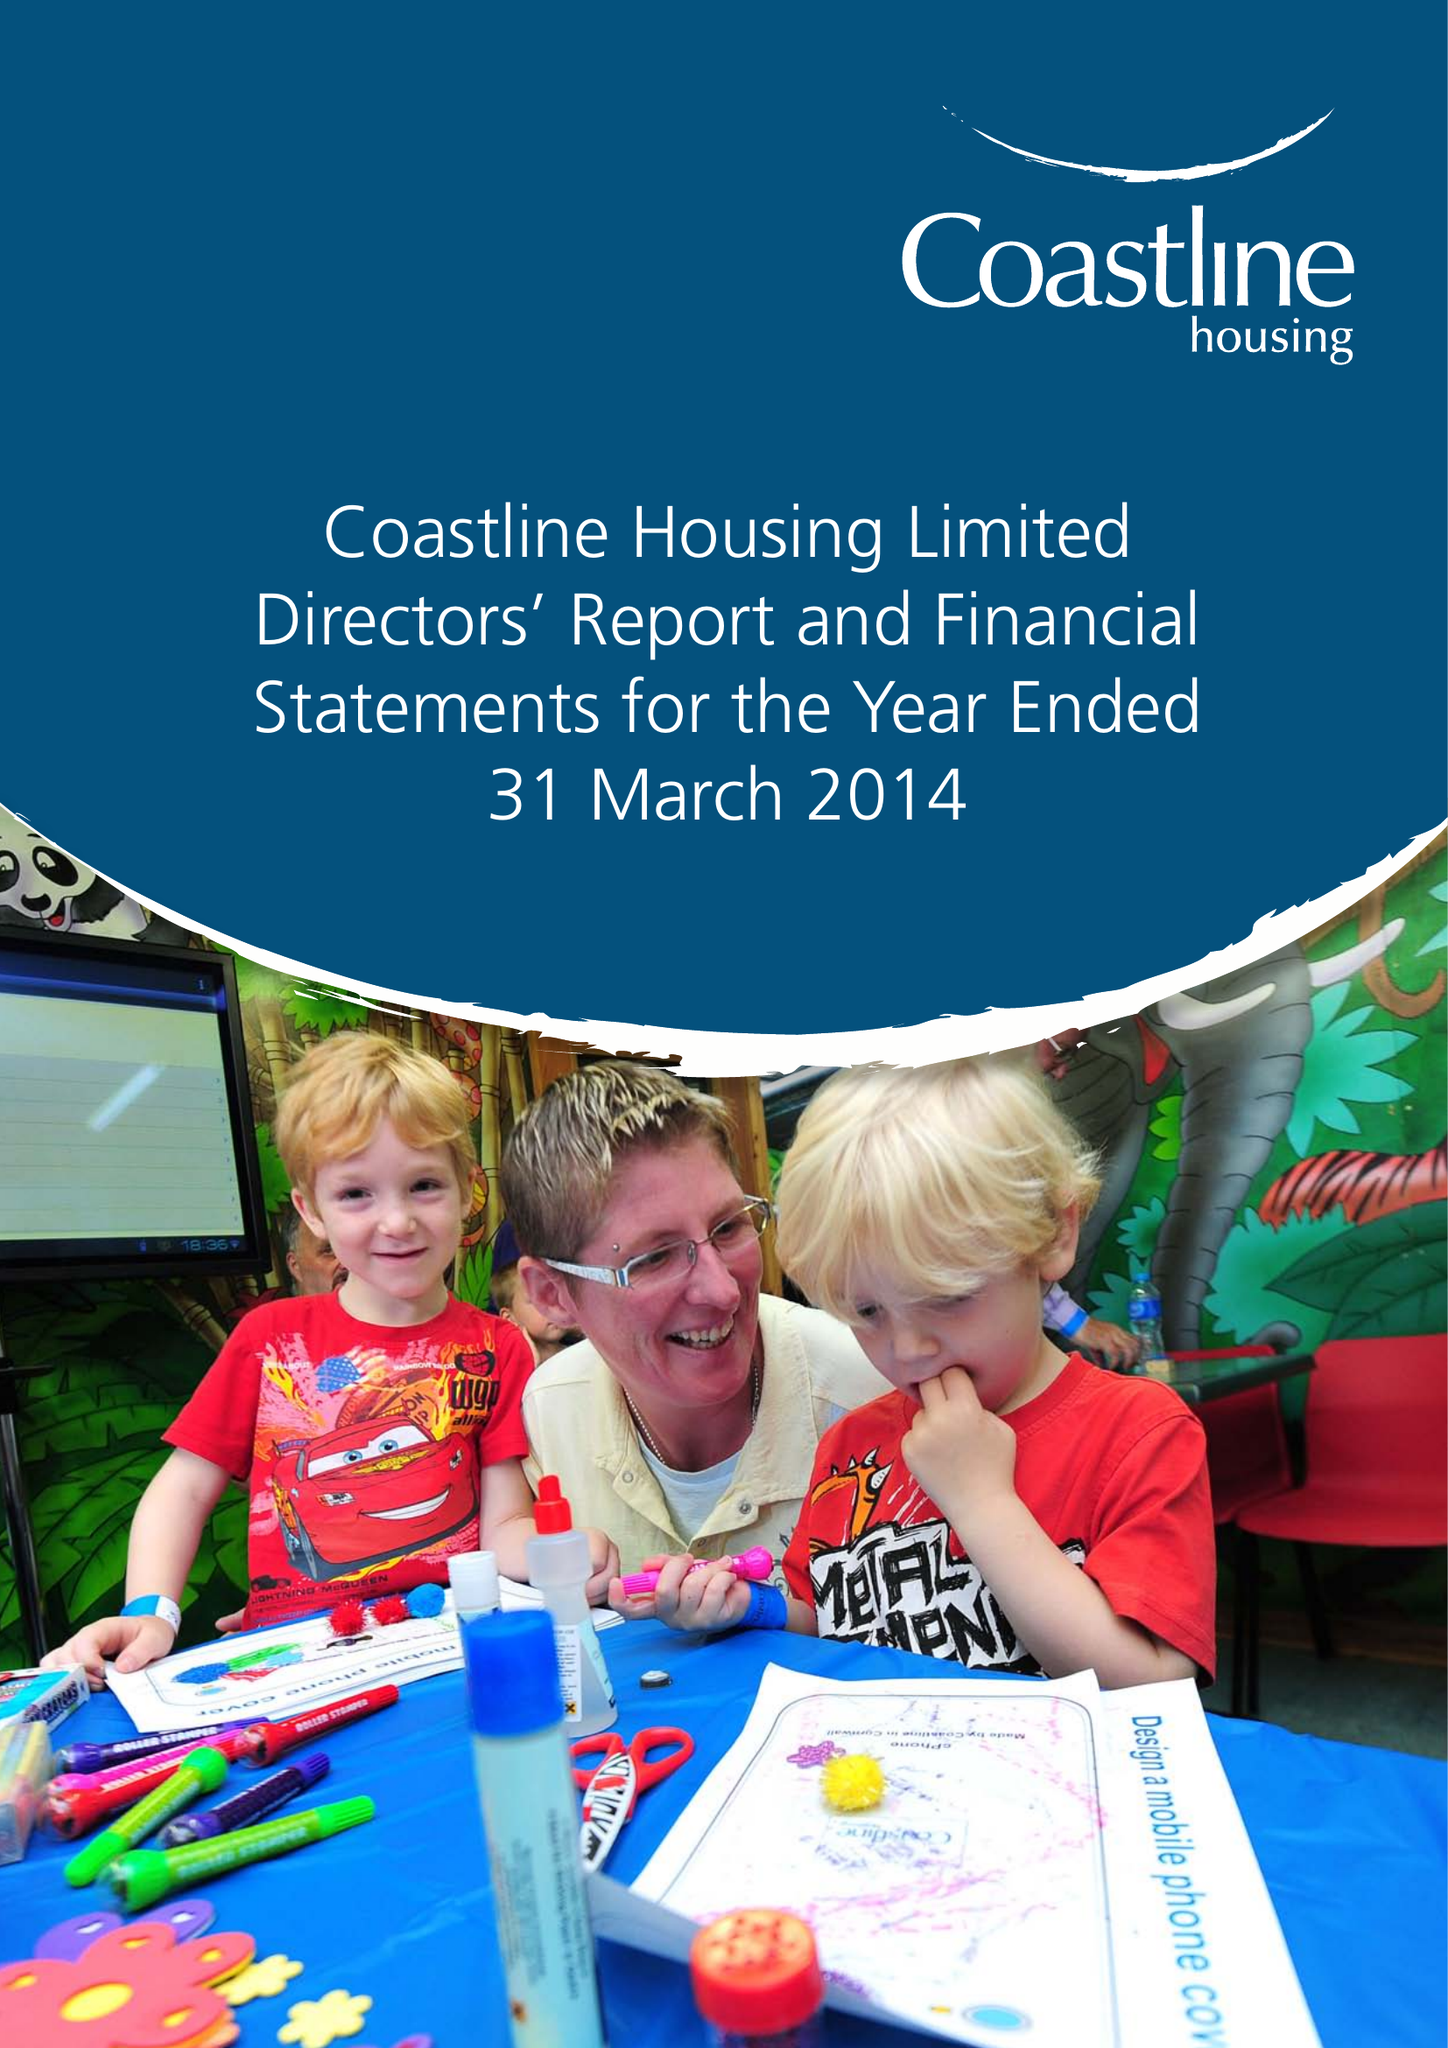What is the value for the address__street_line?
Answer the question using a single word or phrase. None 